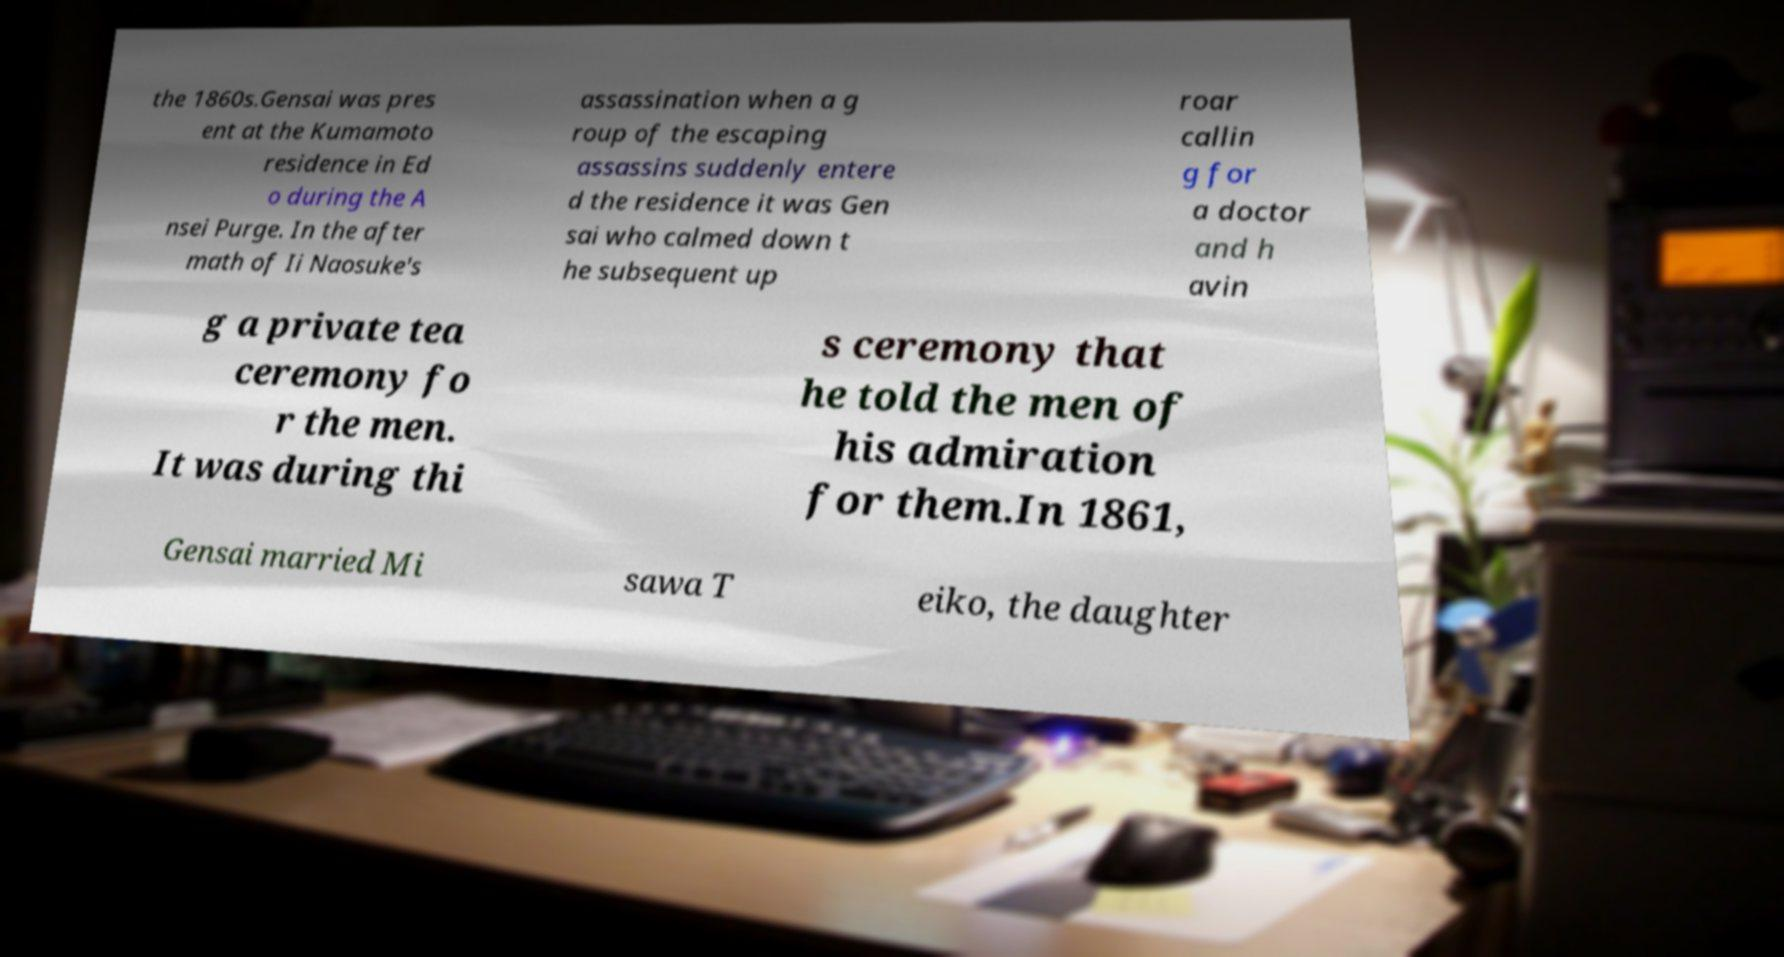There's text embedded in this image that I need extracted. Can you transcribe it verbatim? the 1860s.Gensai was pres ent at the Kumamoto residence in Ed o during the A nsei Purge. In the after math of Ii Naosuke's assassination when a g roup of the escaping assassins suddenly entere d the residence it was Gen sai who calmed down t he subsequent up roar callin g for a doctor and h avin g a private tea ceremony fo r the men. It was during thi s ceremony that he told the men of his admiration for them.In 1861, Gensai married Mi sawa T eiko, the daughter 